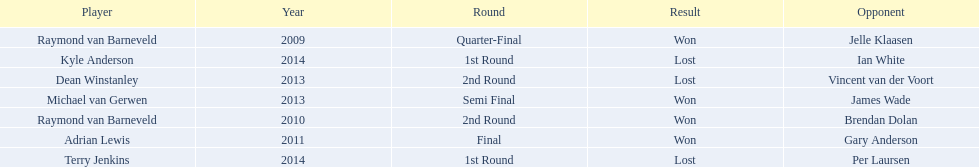Who were all the players? Raymond van Barneveld, Raymond van Barneveld, Adrian Lewis, Dean Winstanley, Michael van Gerwen, Terry Jenkins, Kyle Anderson. Which of these played in 2014? Terry Jenkins, Kyle Anderson. Who were their opponents? Per Laursen, Ian White. Which of these beat terry jenkins? Per Laursen. 